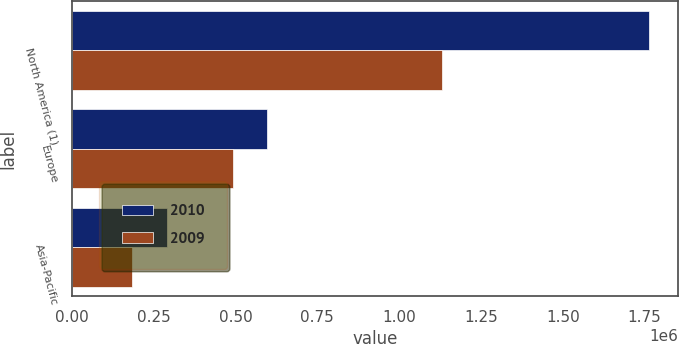Convert chart to OTSL. <chart><loc_0><loc_0><loc_500><loc_500><stacked_bar_chart><ecel><fcel>North America (1)<fcel>Europe<fcel>Asia-Pacific<nl><fcel>2010<fcel>1.76463e+06<fcel>596609<fcel>289714<nl><fcel>2009<fcel>1.13064e+06<fcel>493492<fcel>183986<nl></chart> 